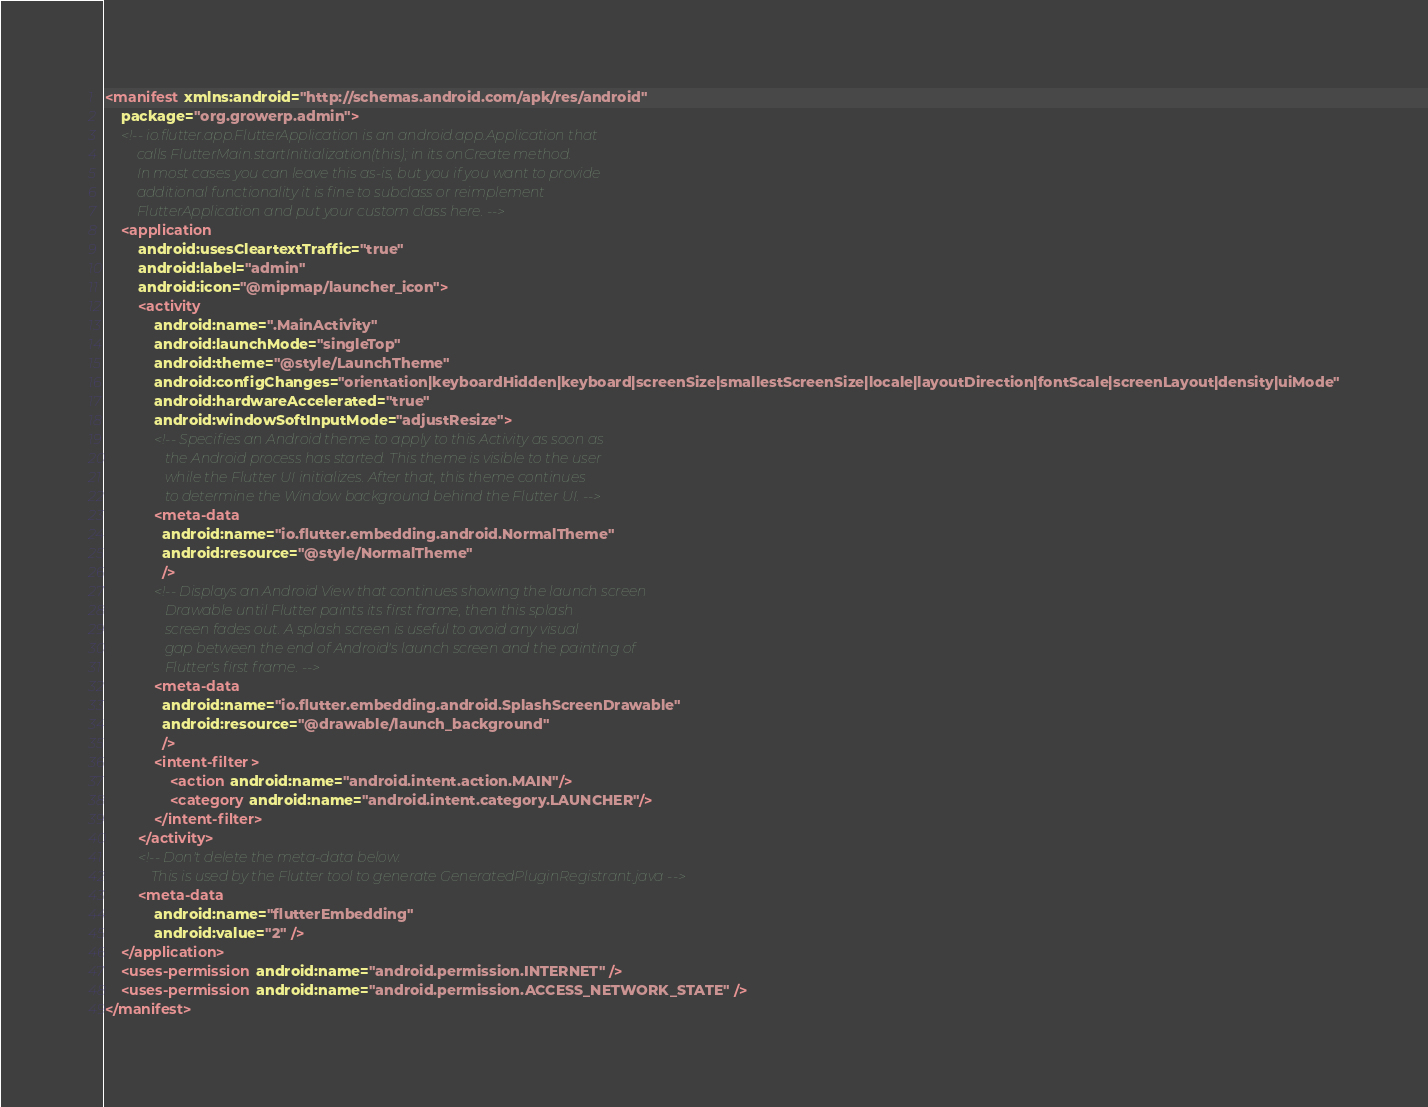<code> <loc_0><loc_0><loc_500><loc_500><_XML_><manifest xmlns:android="http://schemas.android.com/apk/res/android"
    package="org.growerp.admin">
    <!-- io.flutter.app.FlutterApplication is an android.app.Application that
         calls FlutterMain.startInitialization(this); in its onCreate method.
         In most cases you can leave this as-is, but you if you want to provide
         additional functionality it is fine to subclass or reimplement
         FlutterApplication and put your custom class here. -->
    <application
        android:usesCleartextTraffic="true"
        android:label="admin"
        android:icon="@mipmap/launcher_icon">
        <activity
            android:name=".MainActivity"
            android:launchMode="singleTop"
            android:theme="@style/LaunchTheme"
            android:configChanges="orientation|keyboardHidden|keyboard|screenSize|smallestScreenSize|locale|layoutDirection|fontScale|screenLayout|density|uiMode"
            android:hardwareAccelerated="true"
            android:windowSoftInputMode="adjustResize">
            <!-- Specifies an Android theme to apply to this Activity as soon as
                 the Android process has started. This theme is visible to the user
                 while the Flutter UI initializes. After that, this theme continues
                 to determine the Window background behind the Flutter UI. -->
            <meta-data
              android:name="io.flutter.embedding.android.NormalTheme"
              android:resource="@style/NormalTheme"
              />
            <!-- Displays an Android View that continues showing the launch screen
                 Drawable until Flutter paints its first frame, then this splash
                 screen fades out. A splash screen is useful to avoid any visual
                 gap between the end of Android's launch screen and the painting of
                 Flutter's first frame. -->
            <meta-data
              android:name="io.flutter.embedding.android.SplashScreenDrawable"
              android:resource="@drawable/launch_background"
              />
            <intent-filter>
                <action android:name="android.intent.action.MAIN"/>
                <category android:name="android.intent.category.LAUNCHER"/>
            </intent-filter>
        </activity>
        <!-- Don't delete the meta-data below.
             This is used by the Flutter tool to generate GeneratedPluginRegistrant.java -->
        <meta-data
            android:name="flutterEmbedding"
            android:value="2" />
    </application>
    <uses-permission android:name="android.permission.INTERNET" />
    <uses-permission android:name="android.permission.ACCESS_NETWORK_STATE" />
</manifest></code> 